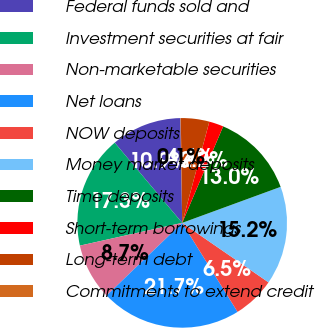<chart> <loc_0><loc_0><loc_500><loc_500><pie_chart><fcel>Federal funds sold and<fcel>Investment securities at fair<fcel>Non-marketable securities<fcel>Net loans<fcel>NOW deposits<fcel>Money market deposits<fcel>Time deposits<fcel>Short-term borrowings<fcel>Long-term debt<fcel>Commitments to extend credit<nl><fcel>10.86%<fcel>17.34%<fcel>8.7%<fcel>21.66%<fcel>6.54%<fcel>15.18%<fcel>13.02%<fcel>2.22%<fcel>4.38%<fcel>0.06%<nl></chart> 